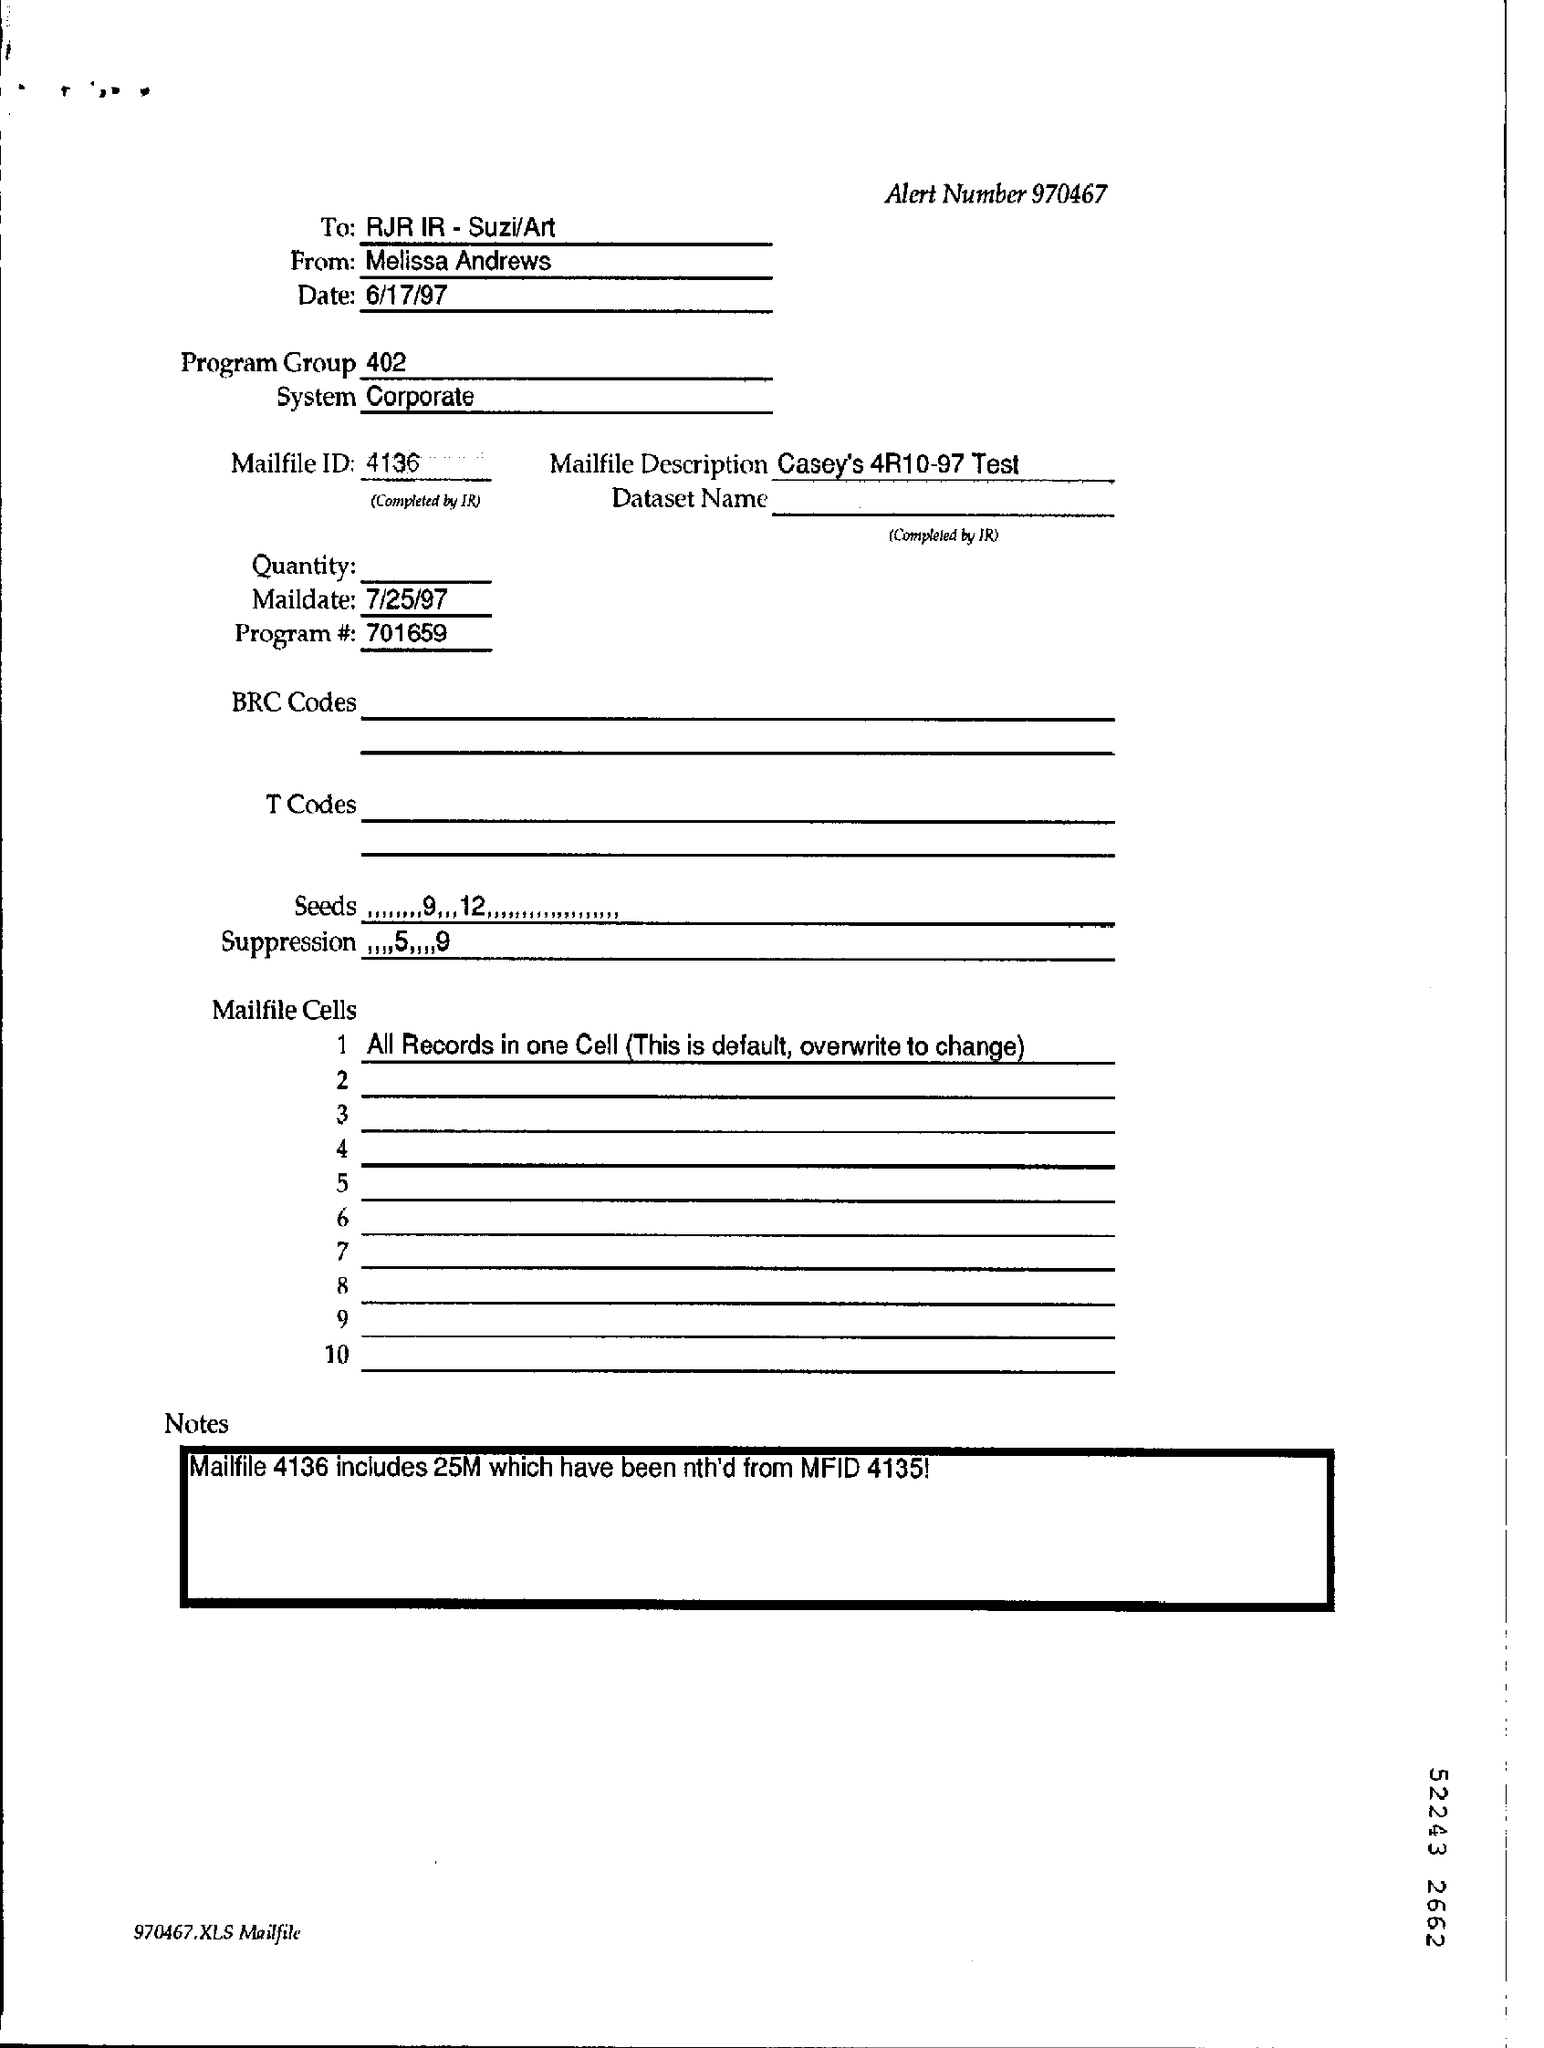Mention a couple of crucial points in this snapshot. The contents of the Program Group are 402... The date at the top of this document is 6/17/97. The System Field contains the text 'Corporate,' indicating that it refers to a corporate entity or organization. The mail date is July 25, 1997. The alert number is 970467... 